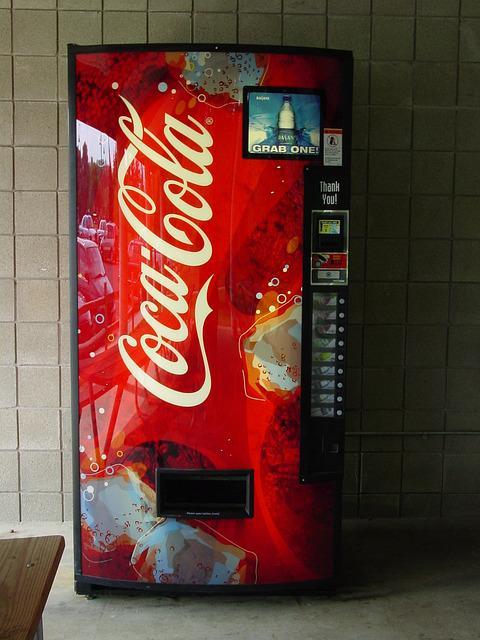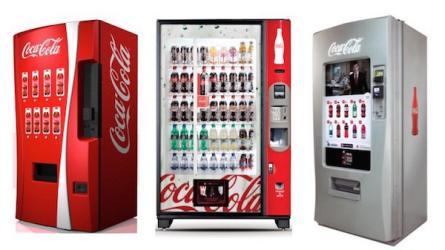The first image is the image on the left, the second image is the image on the right. Considering the images on both sides, is "1 vending machine is the traditional closed-face, single image, cover." valid? Answer yes or no. Yes. The first image is the image on the left, the second image is the image on the right. Analyze the images presented: Is the assertion "In one of the images, there are three machines." valid? Answer yes or no. Yes. 